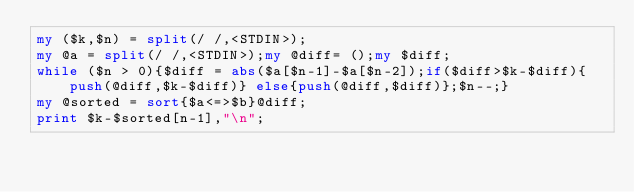<code> <loc_0><loc_0><loc_500><loc_500><_Perl_>my ($k,$n) = split(/ /,<STDIN>);
my @a = split(/ /,<STDIN>);my @diff= ();my $diff;
while ($n > 0){$diff = abs($a[$n-1]-$a[$n-2]);if($diff>$k-$diff){push(@diff,$k-$diff)} else{push(@diff,$diff)};$n--;}
my @sorted = sort{$a<=>$b}@diff;
print $k-$sorted[n-1],"\n";</code> 